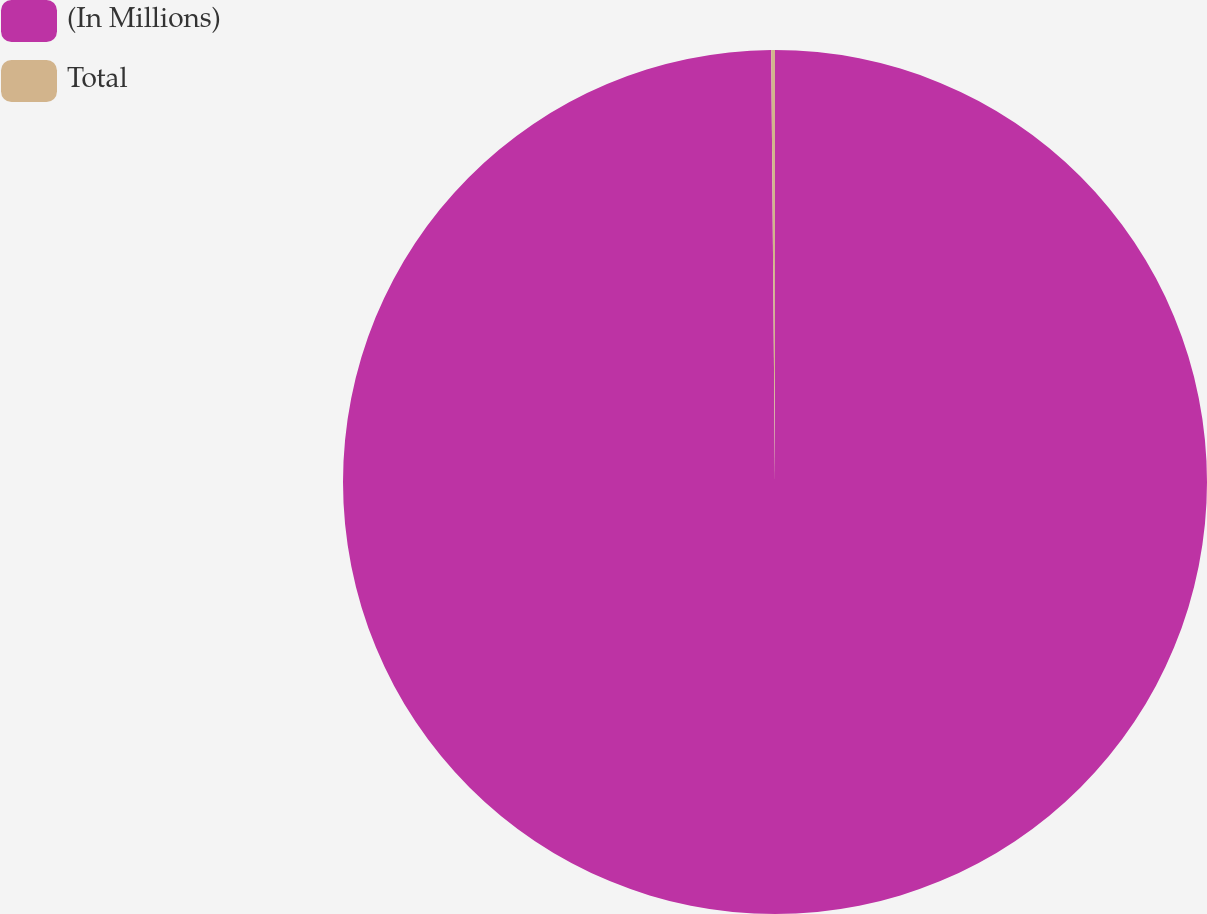<chart> <loc_0><loc_0><loc_500><loc_500><pie_chart><fcel>(In Millions)<fcel>Total<nl><fcel>99.86%<fcel>0.14%<nl></chart> 